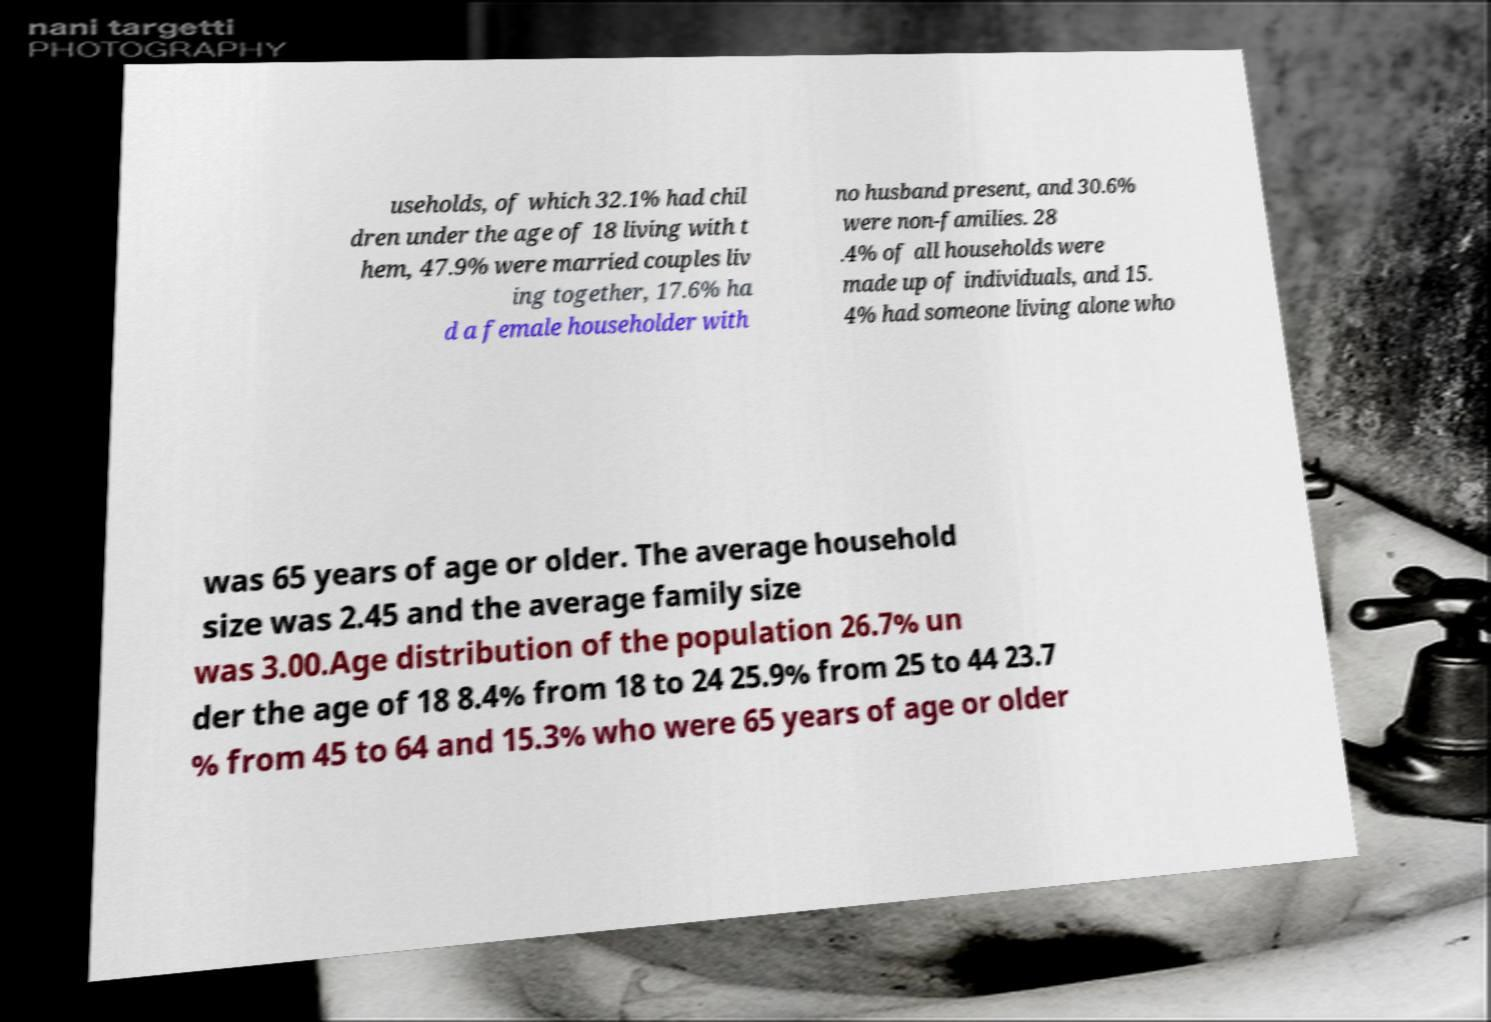Can you accurately transcribe the text from the provided image for me? useholds, of which 32.1% had chil dren under the age of 18 living with t hem, 47.9% were married couples liv ing together, 17.6% ha d a female householder with no husband present, and 30.6% were non-families. 28 .4% of all households were made up of individuals, and 15. 4% had someone living alone who was 65 years of age or older. The average household size was 2.45 and the average family size was 3.00.Age distribution of the population 26.7% un der the age of 18 8.4% from 18 to 24 25.9% from 25 to 44 23.7 % from 45 to 64 and 15.3% who were 65 years of age or older 